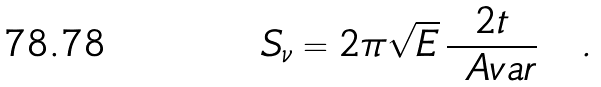<formula> <loc_0><loc_0><loc_500><loc_500>S _ { \nu } = 2 \pi \sqrt { E } \, \frac { 2 t } { \ A v a r } \quad .</formula> 